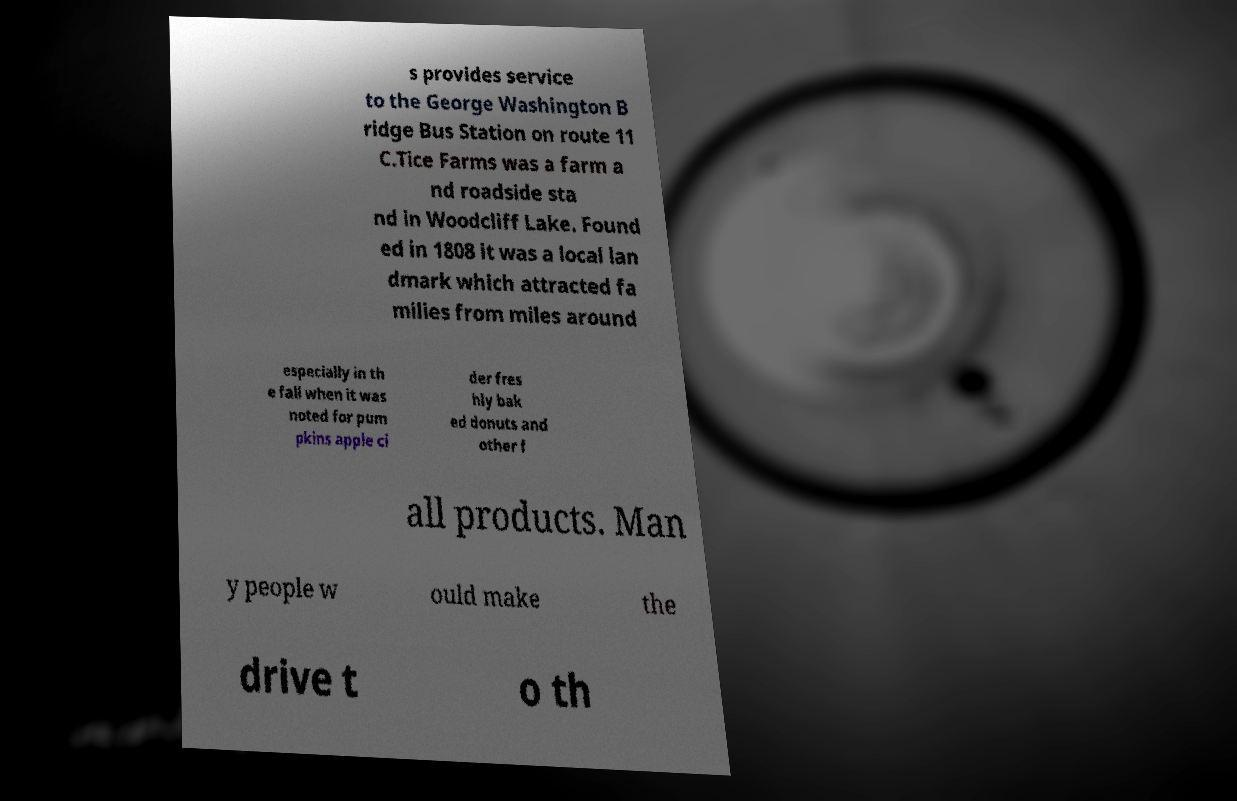For documentation purposes, I need the text within this image transcribed. Could you provide that? s provides service to the George Washington B ridge Bus Station on route 11 C.Tice Farms was a farm a nd roadside sta nd in Woodcliff Lake. Found ed in 1808 it was a local lan dmark which attracted fa milies from miles around especially in th e fall when it was noted for pum pkins apple ci der fres hly bak ed donuts and other f all products. Man y people w ould make the drive t o th 